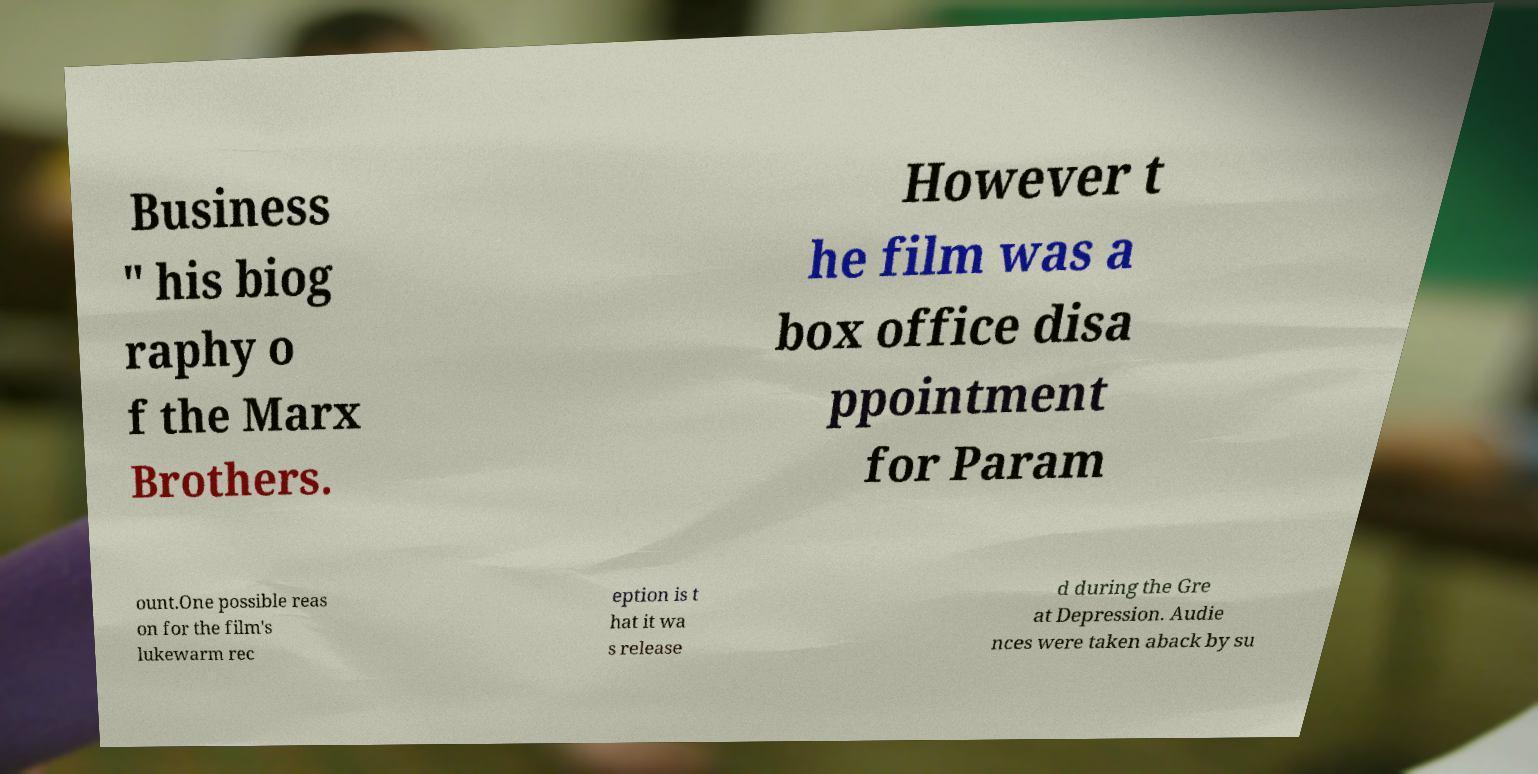Can you read and provide the text displayed in the image?This photo seems to have some interesting text. Can you extract and type it out for me? Business " his biog raphy o f the Marx Brothers. However t he film was a box office disa ppointment for Param ount.One possible reas on for the film's lukewarm rec eption is t hat it wa s release d during the Gre at Depression. Audie nces were taken aback by su 